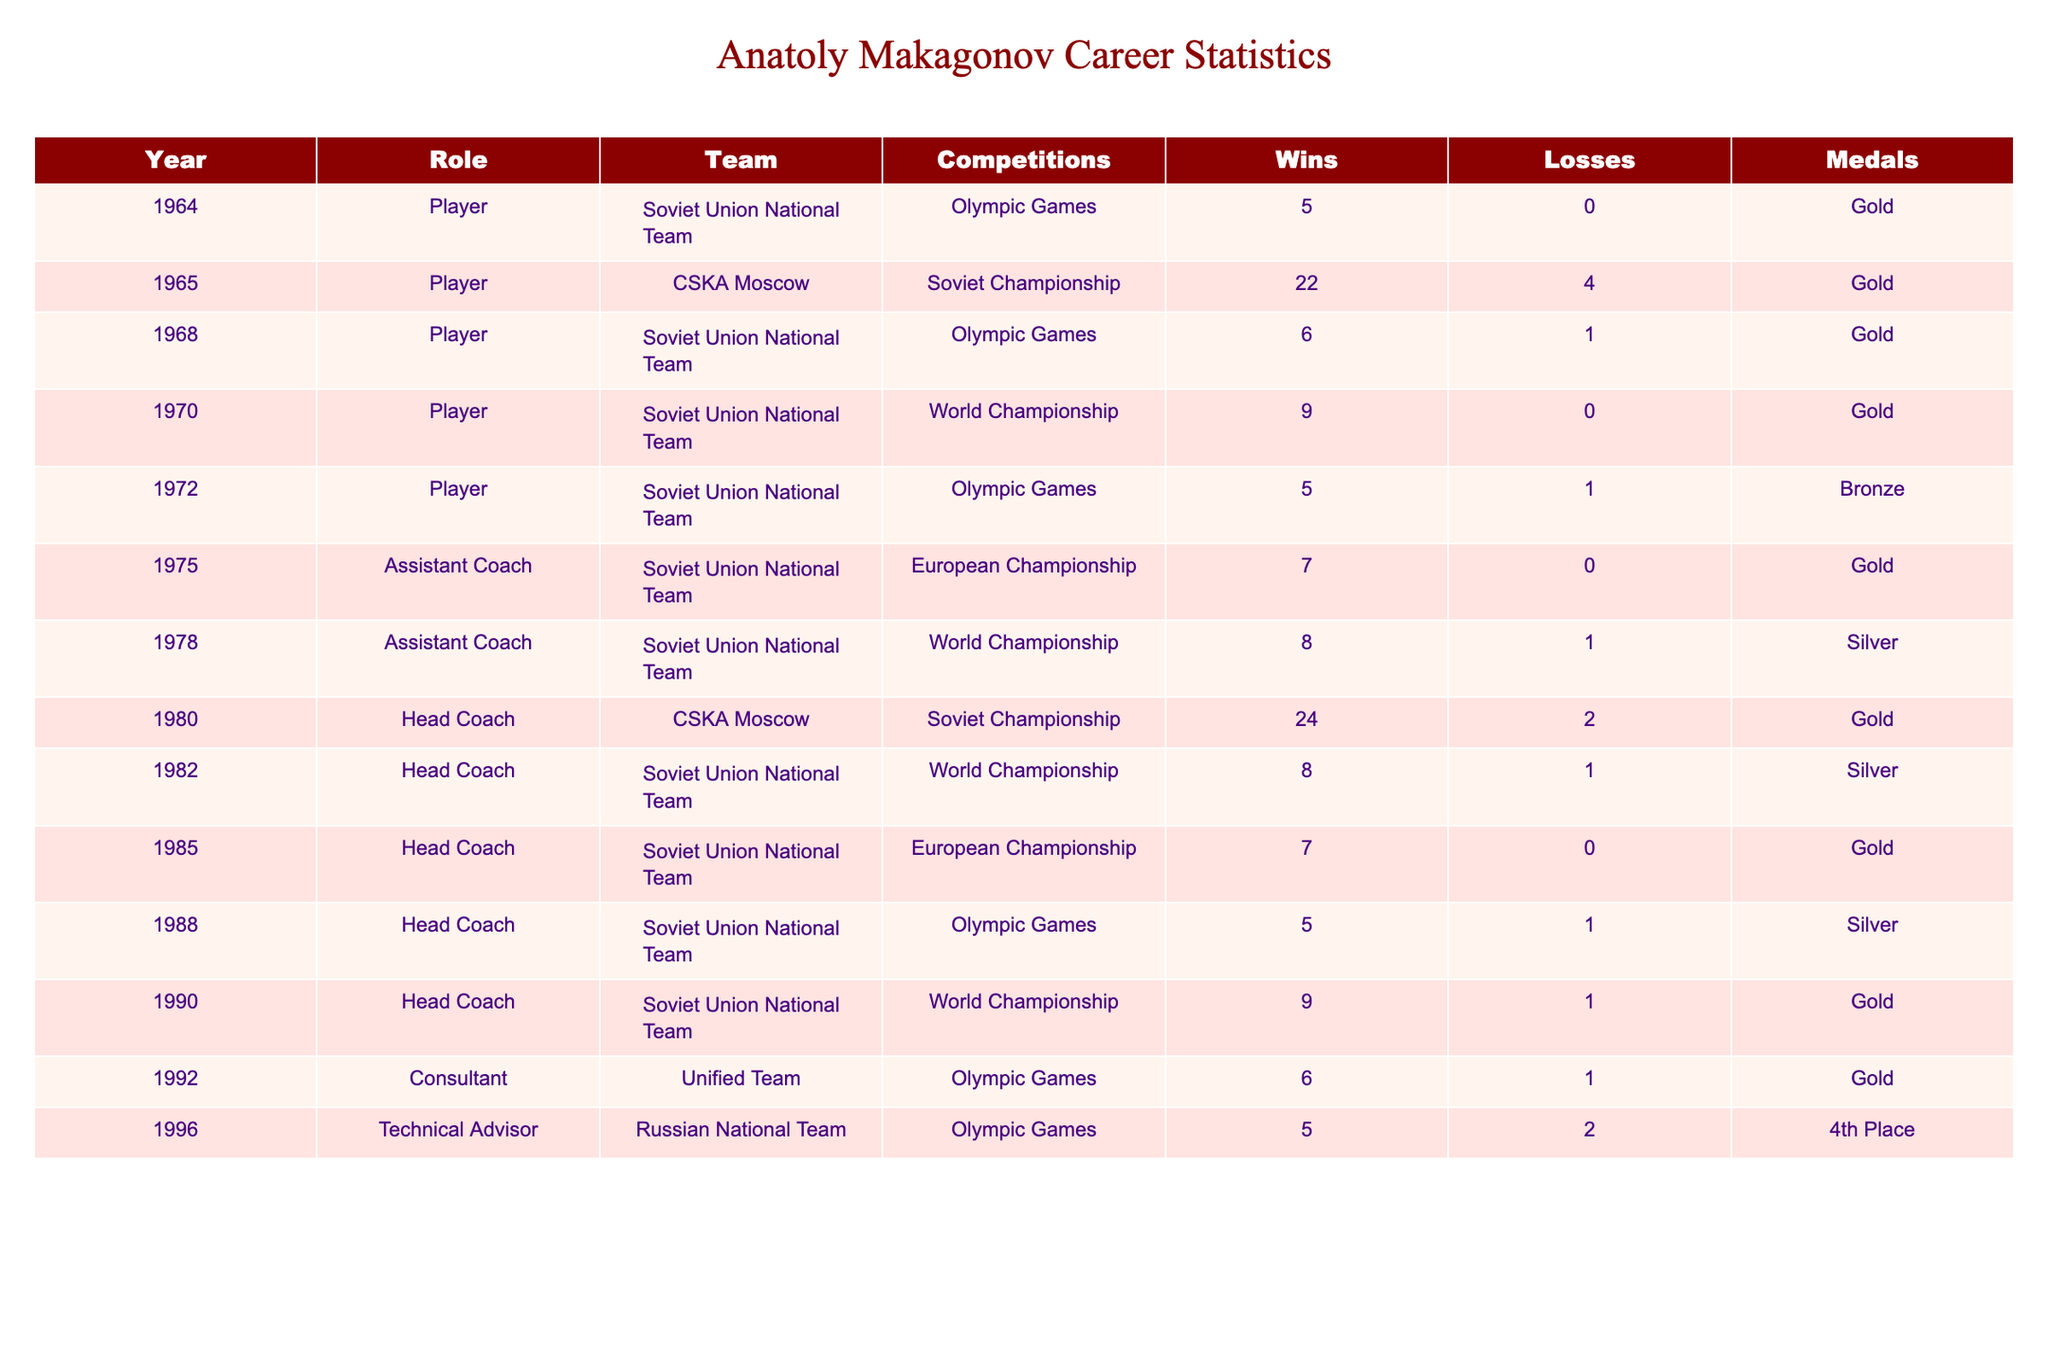What year did Anatoly Makagonov win his first Olympic gold medal as a player? The first Olympic Games where Anatoly Makagonov played and won a gold medal was in 1964.
Answer: 1964 How many total wins did Anatoly Makagonov achieve as a head coach? Summing the wins for each year he was a head coach: 24 (1980) + 8 (1982) + 7 (1985) + 5 (1988) + 9 (1990) = 53.
Answer: 53 Did Anatoly Makagonov ever lose a match as a player in the Soviet Union National Team during Olympic Games? By looking at the records from the Olympic Games where he was a player, all wins were recorded without any losses except for the 1972 event, where he had 1 loss.
Answer: No Which competition did Anatoly Makagonov win the most total medals as a player? He participated in the Olympic Games three times as a player (1964, 1968, 1972) and won gold in 1964, 1968 and bronze in 1972, resulting in three total medals.
Answer: Olympic Games What was the total number of competitions where Anatoly Makagonov served as an assistant coach? He served as an assistant coach in two competitions: the European Championship in 1975 and the World Championship in 1978.
Answer: 2 What was Anatoly Makagonov’s win-loss record in the World Championship as a head coach? Adding up the wins and losses from the World Championship: 8 wins (1982) + 9 wins (1990) and 1 loss (1982) + 1 loss (1990) gives us a record of 17-2.
Answer: 17-2 Which role did Anatoly Makagonov occupy when he achieved his last Olympic gold medal? The last Olympic gold medal was won in 1992 while he was a consultant for the Unified Team.
Answer: Consultant How many total medals did Anatoly Makagonov win throughout his entire career? The total medals are summed as: 6 gold (3 as player, 3 as coach) + 2 silver (as coach) + 1 bronze (as player) = 9 total medals.
Answer: 9 In what year did Anatoly Makagonov have the most losses as a head coach? The year with the most losses as head coach was 1982, with 1 loss in the World Championship.
Answer: 1982 How many competitions did Anatoly Makagonov participate in as a player compared to his coaching roles? He participated in 5 competitions as a player and 6 as a coach.
Answer: 5 as a player, 6 as a coach What is the difference in the number of wins between his time as a player and as a head coach? He had 46 wins as a player (5+22+6+9+5) compared to 53 as a head coach, giving a difference of 53 - 46 = 7.
Answer: 7 